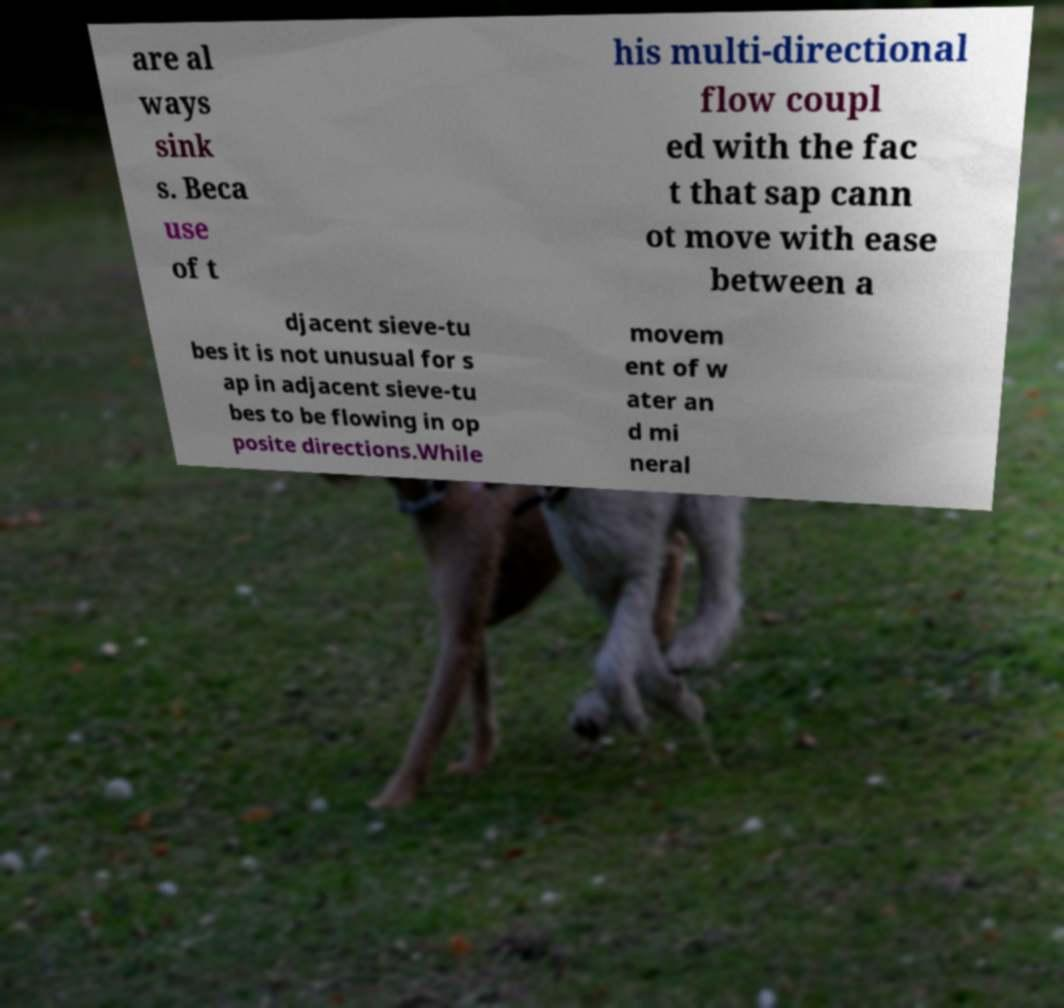Please identify and transcribe the text found in this image. are al ways sink s. Beca use of t his multi-directional flow coupl ed with the fac t that sap cann ot move with ease between a djacent sieve-tu bes it is not unusual for s ap in adjacent sieve-tu bes to be flowing in op posite directions.While movem ent of w ater an d mi neral 